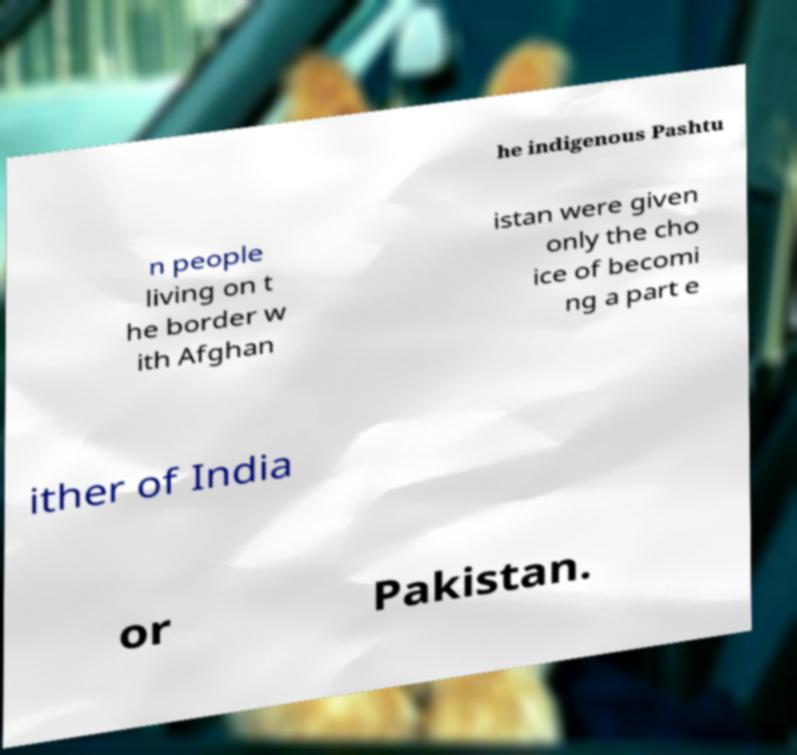Can you read and provide the text displayed in the image?This photo seems to have some interesting text. Can you extract and type it out for me? he indigenous Pashtu n people living on t he border w ith Afghan istan were given only the cho ice of becomi ng a part e ither of India or Pakistan. 